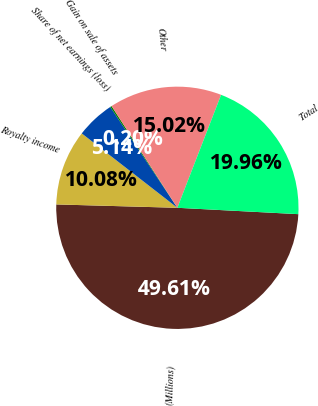Convert chart. <chart><loc_0><loc_0><loc_500><loc_500><pie_chart><fcel>(Millions)<fcel>Royalty income<fcel>Share of net earnings (loss)<fcel>Gain on sale of assets<fcel>Other<fcel>Total<nl><fcel>49.61%<fcel>10.08%<fcel>5.14%<fcel>0.2%<fcel>15.02%<fcel>19.96%<nl></chart> 